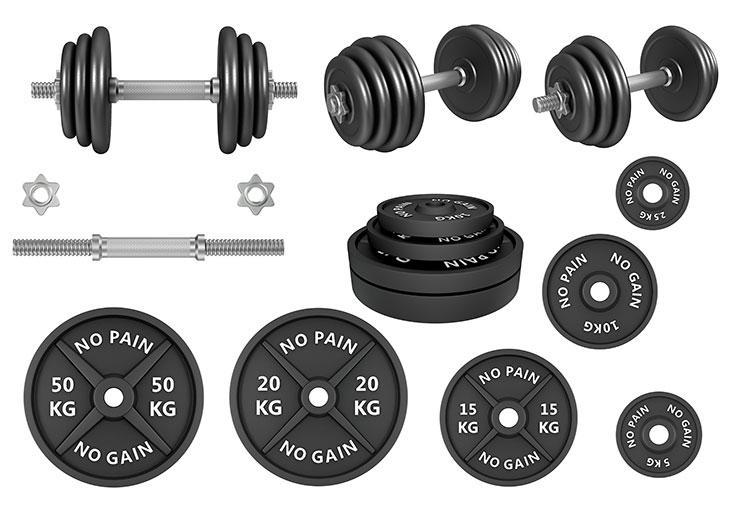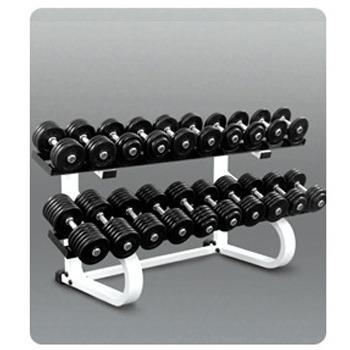The first image is the image on the left, the second image is the image on the right. For the images shown, is this caption "The rack in the image on the right holds more than a dozen weights." true? Answer yes or no. Yes. The first image is the image on the left, the second image is the image on the right. Evaluate the accuracy of this statement regarding the images: "In one of the images there is a large rack full of various sized barbells.". Is it true? Answer yes or no. Yes. 